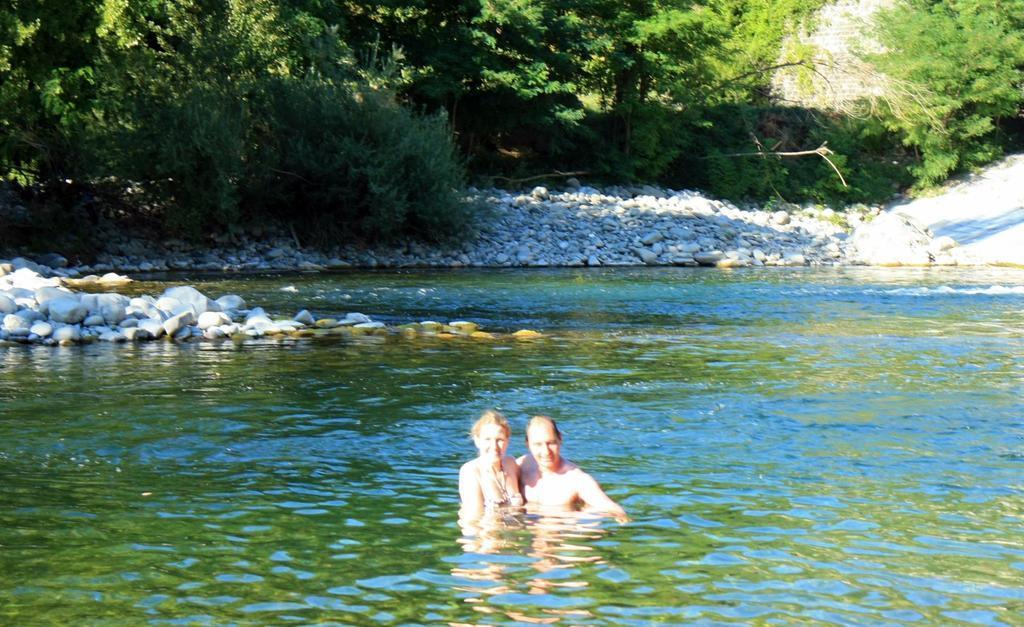How would you summarize this image in a sentence or two? In the image we can see a man and a woman smiling and they are in the water. Here we can see stones, plants and trees. 